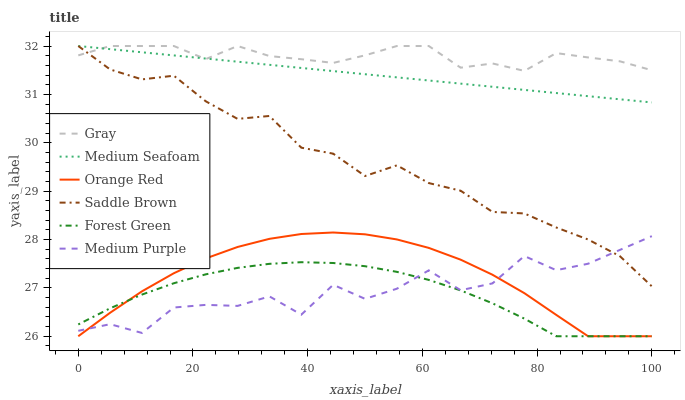Does Forest Green have the minimum area under the curve?
Answer yes or no. Yes. Does Gray have the maximum area under the curve?
Answer yes or no. Yes. Does Orange Red have the minimum area under the curve?
Answer yes or no. No. Does Orange Red have the maximum area under the curve?
Answer yes or no. No. Is Medium Seafoam the smoothest?
Answer yes or no. Yes. Is Medium Purple the roughest?
Answer yes or no. Yes. Is Orange Red the smoothest?
Answer yes or no. No. Is Orange Red the roughest?
Answer yes or no. No. Does Orange Red have the lowest value?
Answer yes or no. Yes. Does Medium Seafoam have the lowest value?
Answer yes or no. No. Does Saddle Brown have the highest value?
Answer yes or no. Yes. Does Orange Red have the highest value?
Answer yes or no. No. Is Medium Purple less than Gray?
Answer yes or no. Yes. Is Gray greater than Orange Red?
Answer yes or no. Yes. Does Orange Red intersect Forest Green?
Answer yes or no. Yes. Is Orange Red less than Forest Green?
Answer yes or no. No. Is Orange Red greater than Forest Green?
Answer yes or no. No. Does Medium Purple intersect Gray?
Answer yes or no. No. 